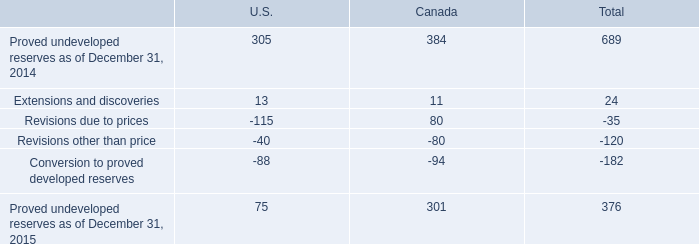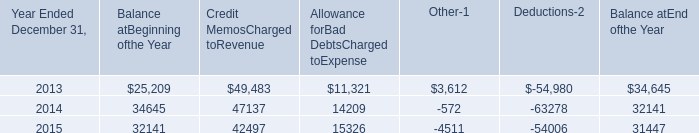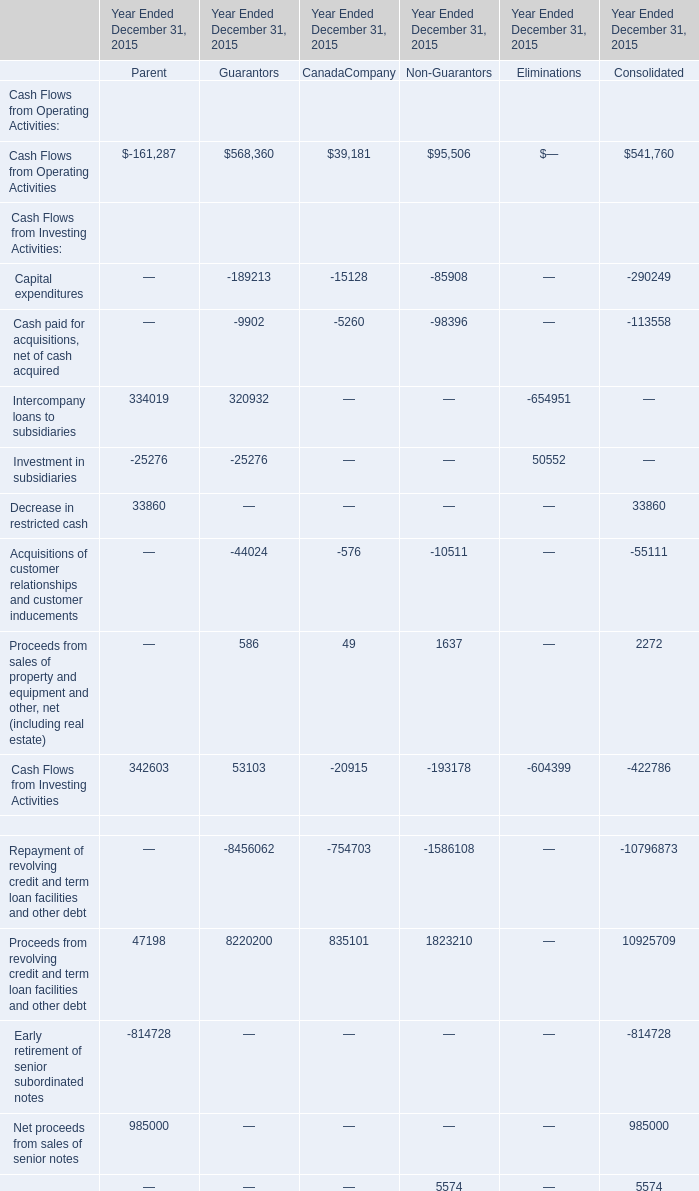what was the total proved reserve amount for the year-end 2015? 
Computations: (376 * (100 / 17))
Answer: 2211.76471. 